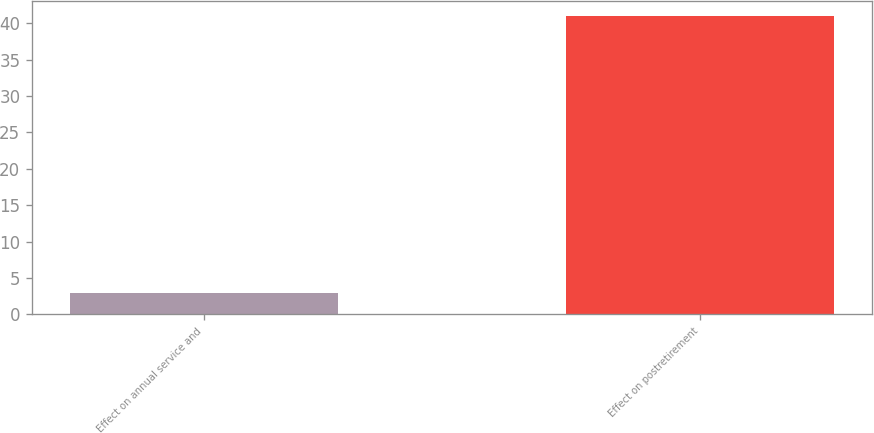Convert chart. <chart><loc_0><loc_0><loc_500><loc_500><bar_chart><fcel>Effect on annual service and<fcel>Effect on postretirement<nl><fcel>3<fcel>41<nl></chart> 